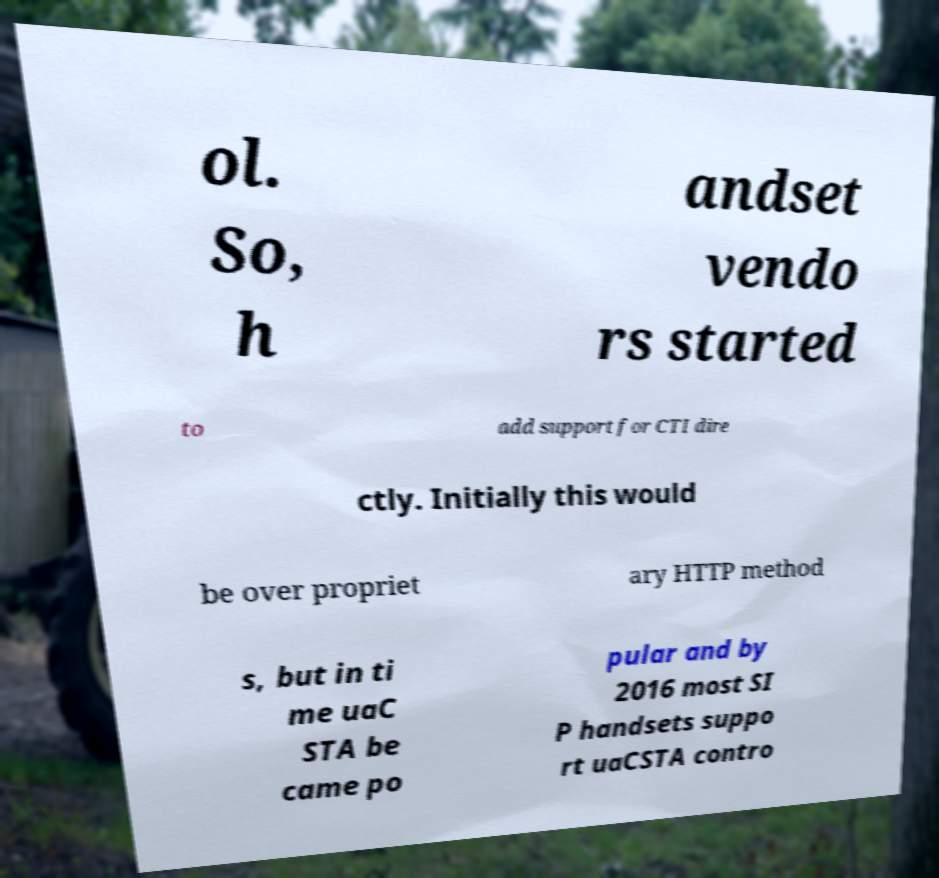Could you assist in decoding the text presented in this image and type it out clearly? ol. So, h andset vendo rs started to add support for CTI dire ctly. Initially this would be over propriet ary HTTP method s, but in ti me uaC STA be came po pular and by 2016 most SI P handsets suppo rt uaCSTA contro 